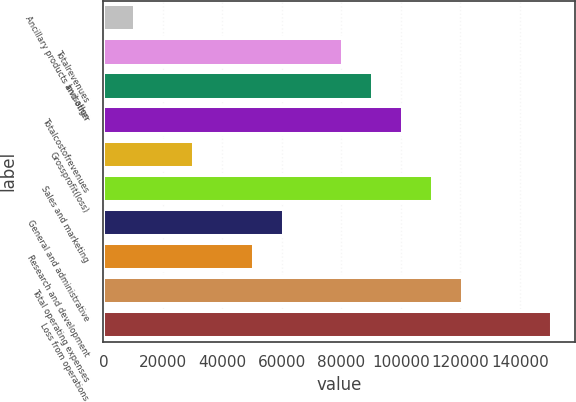Convert chart to OTSL. <chart><loc_0><loc_0><loc_500><loc_500><bar_chart><fcel>Ancillary products and other<fcel>Totalrevenues<fcel>Invisalign<fcel>Totalcostofrevenues<fcel>Grossprofit(loss)<fcel>Sales and marketing<fcel>General and administrative<fcel>Research and development<fcel>Total operating expenses<fcel>Loss from operations<nl><fcel>10555.7<fcel>80721.6<fcel>90745.3<fcel>100769<fcel>30603.1<fcel>110793<fcel>60674.2<fcel>50650.5<fcel>120816<fcel>150888<nl></chart> 